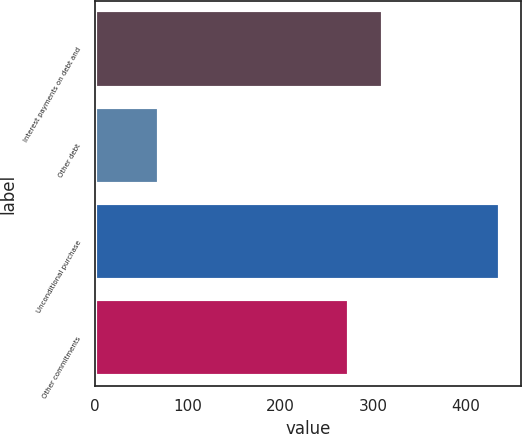<chart> <loc_0><loc_0><loc_500><loc_500><bar_chart><fcel>Interest payments on debt and<fcel>Other debt<fcel>Unconditional purchase<fcel>Other commitments<nl><fcel>310.8<fcel>69<fcel>437<fcel>274<nl></chart> 